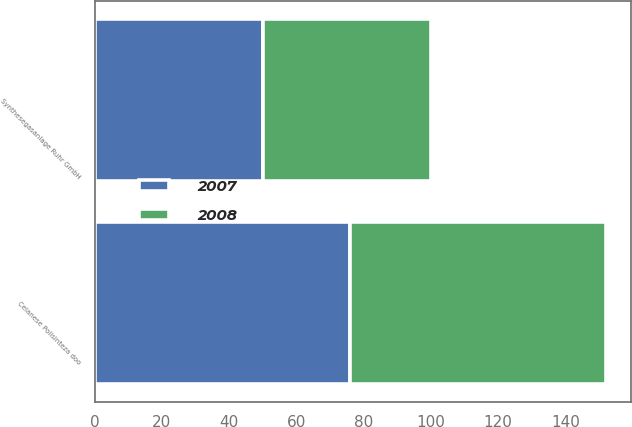Convert chart. <chart><loc_0><loc_0><loc_500><loc_500><stacked_bar_chart><ecel><fcel>Celanese Polisinteza doo<fcel>Synthesegasanlage Ruhr GmbH<nl><fcel>2007<fcel>76<fcel>50<nl><fcel>2008<fcel>76<fcel>50<nl></chart> 